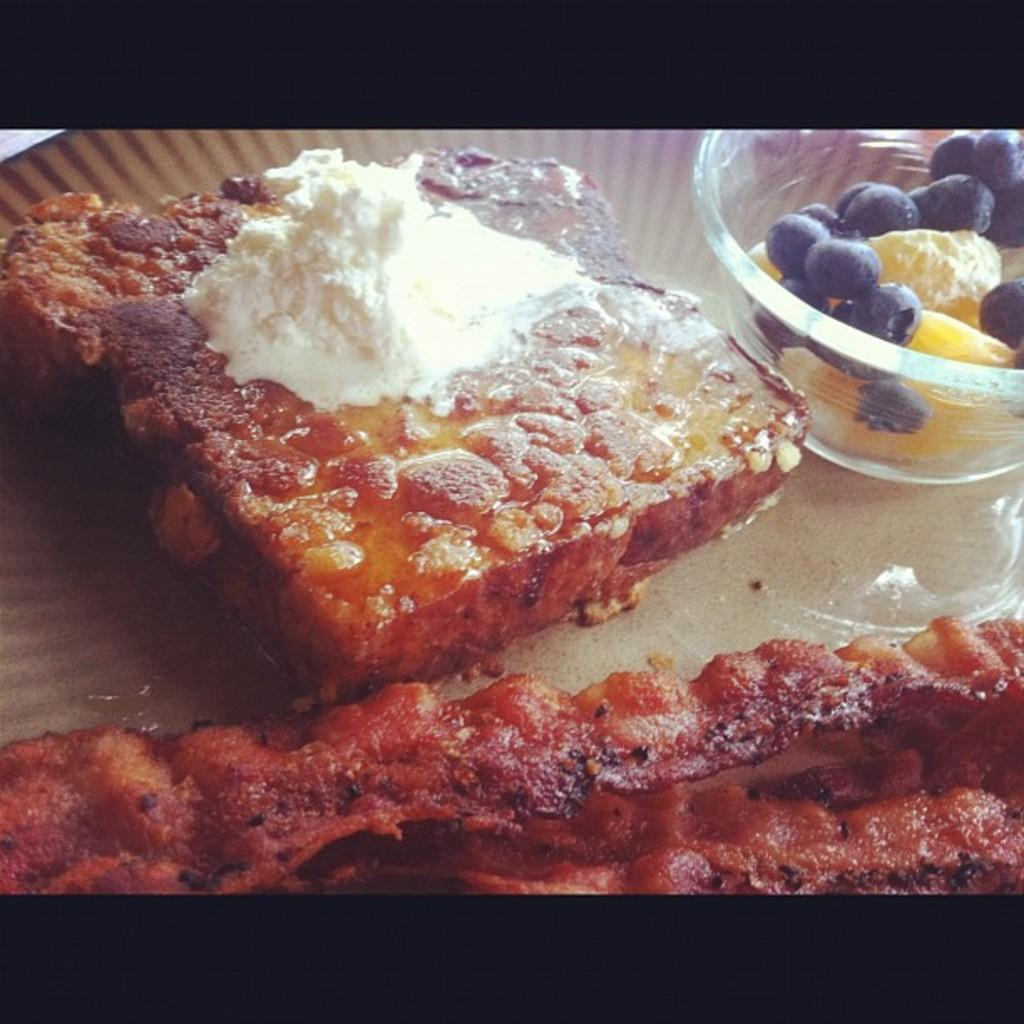What types of items can be seen in the image? There are food items in the image. Where are the food items located? The food items are on an object. What type of sofa is visible in the image? There is no sofa present in the image. Can you describe the spade used for digging in the image? There is no spade or digging activity depicted in the image. 